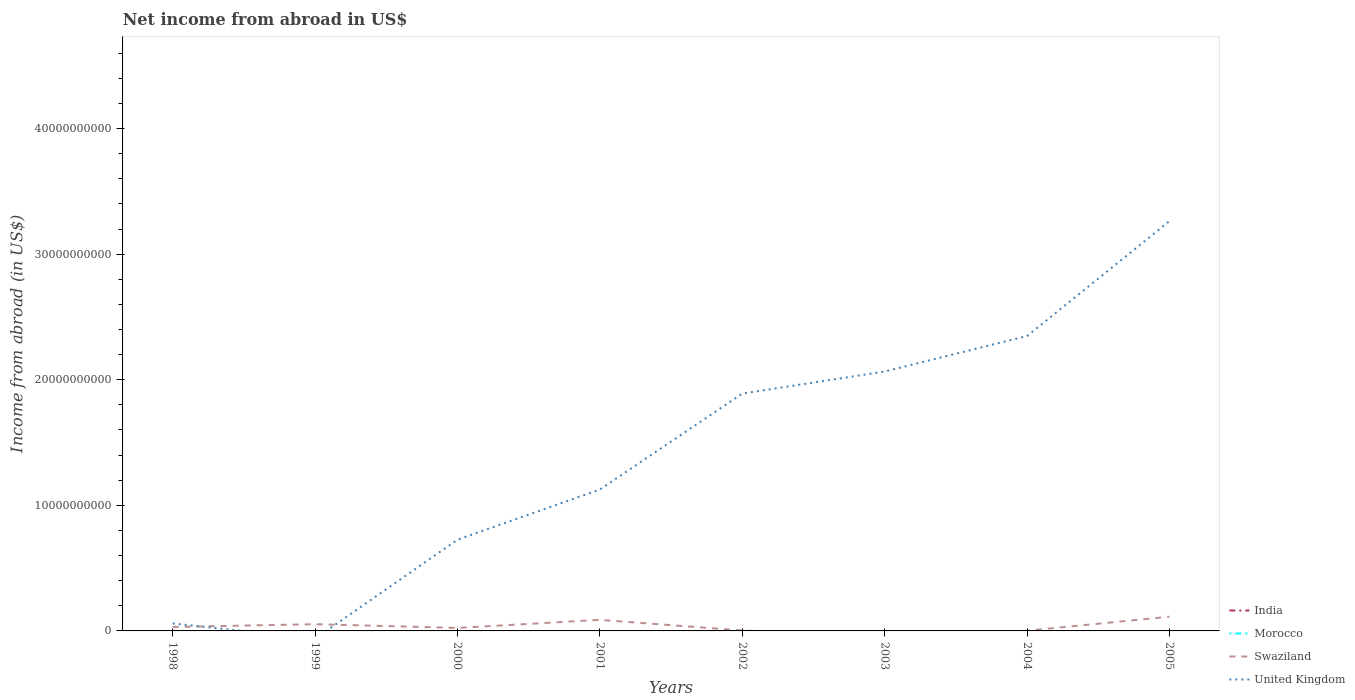How many different coloured lines are there?
Your answer should be compact. 2. Across all years, what is the maximum net income from abroad in Morocco?
Give a very brief answer. 0. What is the total net income from abroad in Swaziland in the graph?
Give a very brief answer. 2.21e+08. What is the difference between the highest and the second highest net income from abroad in United Kingdom?
Your answer should be compact. 3.26e+1. What is the difference between the highest and the lowest net income from abroad in United Kingdom?
Keep it short and to the point. 4. Is the net income from abroad in Swaziland strictly greater than the net income from abroad in United Kingdom over the years?
Offer a terse response. No. How many lines are there?
Provide a short and direct response. 2. How many years are there in the graph?
Offer a very short reply. 8. Does the graph contain any zero values?
Your answer should be very brief. Yes. Where does the legend appear in the graph?
Provide a succinct answer. Bottom right. How many legend labels are there?
Provide a succinct answer. 4. How are the legend labels stacked?
Your response must be concise. Vertical. What is the title of the graph?
Offer a terse response. Net income from abroad in US$. Does "Portugal" appear as one of the legend labels in the graph?
Your answer should be compact. No. What is the label or title of the X-axis?
Offer a very short reply. Years. What is the label or title of the Y-axis?
Provide a succinct answer. Income from abroad (in US$). What is the Income from abroad (in US$) of India in 1998?
Make the answer very short. 0. What is the Income from abroad (in US$) in Swaziland in 1998?
Your response must be concise. 3.15e+08. What is the Income from abroad (in US$) in United Kingdom in 1998?
Your answer should be very brief. 5.96e+08. What is the Income from abroad (in US$) of Swaziland in 1999?
Your answer should be very brief. 5.36e+08. What is the Income from abroad (in US$) in Morocco in 2000?
Your answer should be very brief. 0. What is the Income from abroad (in US$) of Swaziland in 2000?
Your response must be concise. 2.37e+08. What is the Income from abroad (in US$) of United Kingdom in 2000?
Offer a very short reply. 7.26e+09. What is the Income from abroad (in US$) in Swaziland in 2001?
Ensure brevity in your answer.  8.81e+08. What is the Income from abroad (in US$) of United Kingdom in 2001?
Ensure brevity in your answer.  1.13e+1. What is the Income from abroad (in US$) of India in 2002?
Offer a very short reply. 0. What is the Income from abroad (in US$) in Morocco in 2002?
Provide a short and direct response. 0. What is the Income from abroad (in US$) of Swaziland in 2002?
Give a very brief answer. 3.44e+07. What is the Income from abroad (in US$) in United Kingdom in 2002?
Offer a terse response. 1.89e+1. What is the Income from abroad (in US$) of India in 2003?
Provide a succinct answer. 0. What is the Income from abroad (in US$) of United Kingdom in 2003?
Make the answer very short. 2.07e+1. What is the Income from abroad (in US$) in Morocco in 2004?
Your answer should be very brief. 0. What is the Income from abroad (in US$) of Swaziland in 2004?
Offer a terse response. 1.68e+07. What is the Income from abroad (in US$) in United Kingdom in 2004?
Keep it short and to the point. 2.35e+1. What is the Income from abroad (in US$) of India in 2005?
Your answer should be very brief. 0. What is the Income from abroad (in US$) in Swaziland in 2005?
Provide a short and direct response. 1.13e+09. What is the Income from abroad (in US$) of United Kingdom in 2005?
Provide a short and direct response. 3.26e+1. Across all years, what is the maximum Income from abroad (in US$) of Swaziland?
Provide a succinct answer. 1.13e+09. Across all years, what is the maximum Income from abroad (in US$) of United Kingdom?
Offer a terse response. 3.26e+1. Across all years, what is the minimum Income from abroad (in US$) of Swaziland?
Your response must be concise. 0. Across all years, what is the minimum Income from abroad (in US$) of United Kingdom?
Your response must be concise. 0. What is the total Income from abroad (in US$) of India in the graph?
Provide a short and direct response. 0. What is the total Income from abroad (in US$) in Swaziland in the graph?
Offer a terse response. 3.15e+09. What is the total Income from abroad (in US$) of United Kingdom in the graph?
Keep it short and to the point. 1.15e+11. What is the difference between the Income from abroad (in US$) of Swaziland in 1998 and that in 1999?
Provide a short and direct response. -2.21e+08. What is the difference between the Income from abroad (in US$) in Swaziland in 1998 and that in 2000?
Make the answer very short. 7.72e+07. What is the difference between the Income from abroad (in US$) of United Kingdom in 1998 and that in 2000?
Provide a succinct answer. -6.67e+09. What is the difference between the Income from abroad (in US$) of Swaziland in 1998 and that in 2001?
Give a very brief answer. -5.66e+08. What is the difference between the Income from abroad (in US$) in United Kingdom in 1998 and that in 2001?
Give a very brief answer. -1.07e+1. What is the difference between the Income from abroad (in US$) in Swaziland in 1998 and that in 2002?
Keep it short and to the point. 2.80e+08. What is the difference between the Income from abroad (in US$) in United Kingdom in 1998 and that in 2002?
Offer a very short reply. -1.83e+1. What is the difference between the Income from abroad (in US$) in United Kingdom in 1998 and that in 2003?
Ensure brevity in your answer.  -2.01e+1. What is the difference between the Income from abroad (in US$) of Swaziland in 1998 and that in 2004?
Provide a succinct answer. 2.98e+08. What is the difference between the Income from abroad (in US$) of United Kingdom in 1998 and that in 2004?
Offer a very short reply. -2.29e+1. What is the difference between the Income from abroad (in US$) of Swaziland in 1998 and that in 2005?
Make the answer very short. -8.19e+08. What is the difference between the Income from abroad (in US$) in United Kingdom in 1998 and that in 2005?
Your response must be concise. -3.20e+1. What is the difference between the Income from abroad (in US$) of Swaziland in 1999 and that in 2000?
Provide a succinct answer. 2.99e+08. What is the difference between the Income from abroad (in US$) of Swaziland in 1999 and that in 2001?
Give a very brief answer. -3.45e+08. What is the difference between the Income from abroad (in US$) in Swaziland in 1999 and that in 2002?
Offer a terse response. 5.02e+08. What is the difference between the Income from abroad (in US$) of Swaziland in 1999 and that in 2004?
Make the answer very short. 5.19e+08. What is the difference between the Income from abroad (in US$) in Swaziland in 1999 and that in 2005?
Keep it short and to the point. -5.98e+08. What is the difference between the Income from abroad (in US$) in Swaziland in 2000 and that in 2001?
Provide a short and direct response. -6.44e+08. What is the difference between the Income from abroad (in US$) of United Kingdom in 2000 and that in 2001?
Make the answer very short. -4.00e+09. What is the difference between the Income from abroad (in US$) in Swaziland in 2000 and that in 2002?
Offer a very short reply. 2.03e+08. What is the difference between the Income from abroad (in US$) of United Kingdom in 2000 and that in 2002?
Offer a terse response. -1.16e+1. What is the difference between the Income from abroad (in US$) of United Kingdom in 2000 and that in 2003?
Provide a short and direct response. -1.34e+1. What is the difference between the Income from abroad (in US$) of Swaziland in 2000 and that in 2004?
Provide a succinct answer. 2.21e+08. What is the difference between the Income from abroad (in US$) of United Kingdom in 2000 and that in 2004?
Provide a succinct answer. -1.62e+1. What is the difference between the Income from abroad (in US$) in Swaziland in 2000 and that in 2005?
Give a very brief answer. -8.96e+08. What is the difference between the Income from abroad (in US$) in United Kingdom in 2000 and that in 2005?
Keep it short and to the point. -2.54e+1. What is the difference between the Income from abroad (in US$) of Swaziland in 2001 and that in 2002?
Offer a very short reply. 8.47e+08. What is the difference between the Income from abroad (in US$) in United Kingdom in 2001 and that in 2002?
Offer a very short reply. -7.64e+09. What is the difference between the Income from abroad (in US$) in United Kingdom in 2001 and that in 2003?
Provide a short and direct response. -9.40e+09. What is the difference between the Income from abroad (in US$) in Swaziland in 2001 and that in 2004?
Provide a short and direct response. 8.64e+08. What is the difference between the Income from abroad (in US$) in United Kingdom in 2001 and that in 2004?
Your answer should be very brief. -1.22e+1. What is the difference between the Income from abroad (in US$) of Swaziland in 2001 and that in 2005?
Provide a short and direct response. -2.53e+08. What is the difference between the Income from abroad (in US$) in United Kingdom in 2001 and that in 2005?
Give a very brief answer. -2.14e+1. What is the difference between the Income from abroad (in US$) of United Kingdom in 2002 and that in 2003?
Your answer should be very brief. -1.76e+09. What is the difference between the Income from abroad (in US$) of Swaziland in 2002 and that in 2004?
Make the answer very short. 1.76e+07. What is the difference between the Income from abroad (in US$) of United Kingdom in 2002 and that in 2004?
Your response must be concise. -4.58e+09. What is the difference between the Income from abroad (in US$) of Swaziland in 2002 and that in 2005?
Give a very brief answer. -1.10e+09. What is the difference between the Income from abroad (in US$) of United Kingdom in 2002 and that in 2005?
Keep it short and to the point. -1.37e+1. What is the difference between the Income from abroad (in US$) of United Kingdom in 2003 and that in 2004?
Offer a terse response. -2.83e+09. What is the difference between the Income from abroad (in US$) of United Kingdom in 2003 and that in 2005?
Make the answer very short. -1.20e+1. What is the difference between the Income from abroad (in US$) in Swaziland in 2004 and that in 2005?
Ensure brevity in your answer.  -1.12e+09. What is the difference between the Income from abroad (in US$) of United Kingdom in 2004 and that in 2005?
Give a very brief answer. -9.15e+09. What is the difference between the Income from abroad (in US$) in Swaziland in 1998 and the Income from abroad (in US$) in United Kingdom in 2000?
Give a very brief answer. -6.95e+09. What is the difference between the Income from abroad (in US$) of Swaziland in 1998 and the Income from abroad (in US$) of United Kingdom in 2001?
Make the answer very short. -1.09e+1. What is the difference between the Income from abroad (in US$) in Swaziland in 1998 and the Income from abroad (in US$) in United Kingdom in 2002?
Provide a succinct answer. -1.86e+1. What is the difference between the Income from abroad (in US$) in Swaziland in 1998 and the Income from abroad (in US$) in United Kingdom in 2003?
Offer a terse response. -2.03e+1. What is the difference between the Income from abroad (in US$) of Swaziland in 1998 and the Income from abroad (in US$) of United Kingdom in 2004?
Offer a terse response. -2.32e+1. What is the difference between the Income from abroad (in US$) of Swaziland in 1998 and the Income from abroad (in US$) of United Kingdom in 2005?
Keep it short and to the point. -3.23e+1. What is the difference between the Income from abroad (in US$) in Swaziland in 1999 and the Income from abroad (in US$) in United Kingdom in 2000?
Ensure brevity in your answer.  -6.73e+09. What is the difference between the Income from abroad (in US$) in Swaziland in 1999 and the Income from abroad (in US$) in United Kingdom in 2001?
Provide a short and direct response. -1.07e+1. What is the difference between the Income from abroad (in US$) of Swaziland in 1999 and the Income from abroad (in US$) of United Kingdom in 2002?
Provide a short and direct response. -1.84e+1. What is the difference between the Income from abroad (in US$) in Swaziland in 1999 and the Income from abroad (in US$) in United Kingdom in 2003?
Your response must be concise. -2.01e+1. What is the difference between the Income from abroad (in US$) in Swaziland in 1999 and the Income from abroad (in US$) in United Kingdom in 2004?
Your answer should be compact. -2.29e+1. What is the difference between the Income from abroad (in US$) of Swaziland in 1999 and the Income from abroad (in US$) of United Kingdom in 2005?
Keep it short and to the point. -3.21e+1. What is the difference between the Income from abroad (in US$) of Swaziland in 2000 and the Income from abroad (in US$) of United Kingdom in 2001?
Make the answer very short. -1.10e+1. What is the difference between the Income from abroad (in US$) in Swaziland in 2000 and the Income from abroad (in US$) in United Kingdom in 2002?
Ensure brevity in your answer.  -1.87e+1. What is the difference between the Income from abroad (in US$) of Swaziland in 2000 and the Income from abroad (in US$) of United Kingdom in 2003?
Make the answer very short. -2.04e+1. What is the difference between the Income from abroad (in US$) of Swaziland in 2000 and the Income from abroad (in US$) of United Kingdom in 2004?
Your answer should be compact. -2.32e+1. What is the difference between the Income from abroad (in US$) in Swaziland in 2000 and the Income from abroad (in US$) in United Kingdom in 2005?
Your answer should be compact. -3.24e+1. What is the difference between the Income from abroad (in US$) of Swaziland in 2001 and the Income from abroad (in US$) of United Kingdom in 2002?
Offer a terse response. -1.80e+1. What is the difference between the Income from abroad (in US$) in Swaziland in 2001 and the Income from abroad (in US$) in United Kingdom in 2003?
Provide a succinct answer. -1.98e+1. What is the difference between the Income from abroad (in US$) in Swaziland in 2001 and the Income from abroad (in US$) in United Kingdom in 2004?
Give a very brief answer. -2.26e+1. What is the difference between the Income from abroad (in US$) in Swaziland in 2001 and the Income from abroad (in US$) in United Kingdom in 2005?
Your response must be concise. -3.17e+1. What is the difference between the Income from abroad (in US$) in Swaziland in 2002 and the Income from abroad (in US$) in United Kingdom in 2003?
Keep it short and to the point. -2.06e+1. What is the difference between the Income from abroad (in US$) in Swaziland in 2002 and the Income from abroad (in US$) in United Kingdom in 2004?
Offer a very short reply. -2.34e+1. What is the difference between the Income from abroad (in US$) in Swaziland in 2002 and the Income from abroad (in US$) in United Kingdom in 2005?
Your answer should be compact. -3.26e+1. What is the difference between the Income from abroad (in US$) of Swaziland in 2004 and the Income from abroad (in US$) of United Kingdom in 2005?
Your answer should be compact. -3.26e+1. What is the average Income from abroad (in US$) of Swaziland per year?
Ensure brevity in your answer.  3.94e+08. What is the average Income from abroad (in US$) of United Kingdom per year?
Make the answer very short. 1.43e+1. In the year 1998, what is the difference between the Income from abroad (in US$) of Swaziland and Income from abroad (in US$) of United Kingdom?
Give a very brief answer. -2.81e+08. In the year 2000, what is the difference between the Income from abroad (in US$) in Swaziland and Income from abroad (in US$) in United Kingdom?
Make the answer very short. -7.03e+09. In the year 2001, what is the difference between the Income from abroad (in US$) of Swaziland and Income from abroad (in US$) of United Kingdom?
Keep it short and to the point. -1.04e+1. In the year 2002, what is the difference between the Income from abroad (in US$) in Swaziland and Income from abroad (in US$) in United Kingdom?
Make the answer very short. -1.89e+1. In the year 2004, what is the difference between the Income from abroad (in US$) in Swaziland and Income from abroad (in US$) in United Kingdom?
Provide a short and direct response. -2.35e+1. In the year 2005, what is the difference between the Income from abroad (in US$) of Swaziland and Income from abroad (in US$) of United Kingdom?
Your response must be concise. -3.15e+1. What is the ratio of the Income from abroad (in US$) in Swaziland in 1998 to that in 1999?
Make the answer very short. 0.59. What is the ratio of the Income from abroad (in US$) in Swaziland in 1998 to that in 2000?
Keep it short and to the point. 1.33. What is the ratio of the Income from abroad (in US$) in United Kingdom in 1998 to that in 2000?
Give a very brief answer. 0.08. What is the ratio of the Income from abroad (in US$) of Swaziland in 1998 to that in 2001?
Keep it short and to the point. 0.36. What is the ratio of the Income from abroad (in US$) of United Kingdom in 1998 to that in 2001?
Your answer should be very brief. 0.05. What is the ratio of the Income from abroad (in US$) in Swaziland in 1998 to that in 2002?
Offer a very short reply. 9.14. What is the ratio of the Income from abroad (in US$) in United Kingdom in 1998 to that in 2002?
Provide a short and direct response. 0.03. What is the ratio of the Income from abroad (in US$) in United Kingdom in 1998 to that in 2003?
Your response must be concise. 0.03. What is the ratio of the Income from abroad (in US$) in Swaziland in 1998 to that in 2004?
Your response must be concise. 18.71. What is the ratio of the Income from abroad (in US$) in United Kingdom in 1998 to that in 2004?
Offer a terse response. 0.03. What is the ratio of the Income from abroad (in US$) in Swaziland in 1998 to that in 2005?
Keep it short and to the point. 0.28. What is the ratio of the Income from abroad (in US$) of United Kingdom in 1998 to that in 2005?
Your answer should be compact. 0.02. What is the ratio of the Income from abroad (in US$) of Swaziland in 1999 to that in 2000?
Offer a very short reply. 2.26. What is the ratio of the Income from abroad (in US$) of Swaziland in 1999 to that in 2001?
Your response must be concise. 0.61. What is the ratio of the Income from abroad (in US$) in Swaziland in 1999 to that in 2002?
Your answer should be compact. 15.58. What is the ratio of the Income from abroad (in US$) in Swaziland in 1999 to that in 2004?
Your answer should be very brief. 31.88. What is the ratio of the Income from abroad (in US$) in Swaziland in 1999 to that in 2005?
Provide a succinct answer. 0.47. What is the ratio of the Income from abroad (in US$) of Swaziland in 2000 to that in 2001?
Provide a succinct answer. 0.27. What is the ratio of the Income from abroad (in US$) of United Kingdom in 2000 to that in 2001?
Provide a succinct answer. 0.65. What is the ratio of the Income from abroad (in US$) in Swaziland in 2000 to that in 2002?
Offer a terse response. 6.9. What is the ratio of the Income from abroad (in US$) of United Kingdom in 2000 to that in 2002?
Keep it short and to the point. 0.38. What is the ratio of the Income from abroad (in US$) of United Kingdom in 2000 to that in 2003?
Make the answer very short. 0.35. What is the ratio of the Income from abroad (in US$) in Swaziland in 2000 to that in 2004?
Provide a short and direct response. 14.12. What is the ratio of the Income from abroad (in US$) in United Kingdom in 2000 to that in 2004?
Ensure brevity in your answer.  0.31. What is the ratio of the Income from abroad (in US$) of Swaziland in 2000 to that in 2005?
Make the answer very short. 0.21. What is the ratio of the Income from abroad (in US$) in United Kingdom in 2000 to that in 2005?
Provide a succinct answer. 0.22. What is the ratio of the Income from abroad (in US$) in Swaziland in 2001 to that in 2002?
Your response must be concise. 25.61. What is the ratio of the Income from abroad (in US$) of United Kingdom in 2001 to that in 2002?
Provide a succinct answer. 0.6. What is the ratio of the Income from abroad (in US$) of United Kingdom in 2001 to that in 2003?
Your answer should be very brief. 0.55. What is the ratio of the Income from abroad (in US$) of Swaziland in 2001 to that in 2004?
Keep it short and to the point. 52.41. What is the ratio of the Income from abroad (in US$) in United Kingdom in 2001 to that in 2004?
Ensure brevity in your answer.  0.48. What is the ratio of the Income from abroad (in US$) in Swaziland in 2001 to that in 2005?
Offer a very short reply. 0.78. What is the ratio of the Income from abroad (in US$) of United Kingdom in 2001 to that in 2005?
Your response must be concise. 0.35. What is the ratio of the Income from abroad (in US$) of United Kingdom in 2002 to that in 2003?
Give a very brief answer. 0.91. What is the ratio of the Income from abroad (in US$) of Swaziland in 2002 to that in 2004?
Your response must be concise. 2.05. What is the ratio of the Income from abroad (in US$) of United Kingdom in 2002 to that in 2004?
Provide a short and direct response. 0.8. What is the ratio of the Income from abroad (in US$) in Swaziland in 2002 to that in 2005?
Provide a short and direct response. 0.03. What is the ratio of the Income from abroad (in US$) of United Kingdom in 2002 to that in 2005?
Keep it short and to the point. 0.58. What is the ratio of the Income from abroad (in US$) in United Kingdom in 2003 to that in 2004?
Your answer should be compact. 0.88. What is the ratio of the Income from abroad (in US$) of United Kingdom in 2003 to that in 2005?
Keep it short and to the point. 0.63. What is the ratio of the Income from abroad (in US$) of Swaziland in 2004 to that in 2005?
Offer a very short reply. 0.01. What is the ratio of the Income from abroad (in US$) in United Kingdom in 2004 to that in 2005?
Provide a succinct answer. 0.72. What is the difference between the highest and the second highest Income from abroad (in US$) of Swaziland?
Provide a short and direct response. 2.53e+08. What is the difference between the highest and the second highest Income from abroad (in US$) of United Kingdom?
Your answer should be very brief. 9.15e+09. What is the difference between the highest and the lowest Income from abroad (in US$) in Swaziland?
Offer a terse response. 1.13e+09. What is the difference between the highest and the lowest Income from abroad (in US$) of United Kingdom?
Offer a terse response. 3.26e+1. 